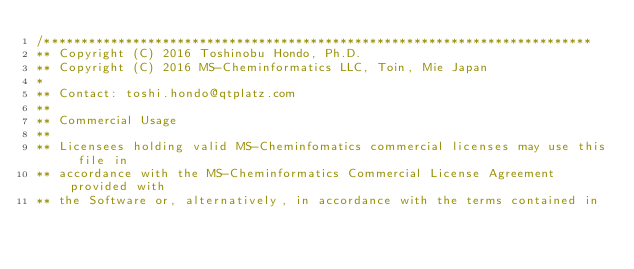Convert code to text. <code><loc_0><loc_0><loc_500><loc_500><_C_>/**************************************************************************
** Copyright (C) 2016 Toshinobu Hondo, Ph.D.
** Copyright (C) 2016 MS-Cheminformatics LLC, Toin, Mie Japan
*
** Contact: toshi.hondo@qtplatz.com
**
** Commercial Usage
**
** Licensees holding valid MS-Cheminfomatics commercial licenses may use this file in
** accordance with the MS-Cheminformatics Commercial License Agreement provided with
** the Software or, alternatively, in accordance with the terms contained in</code> 